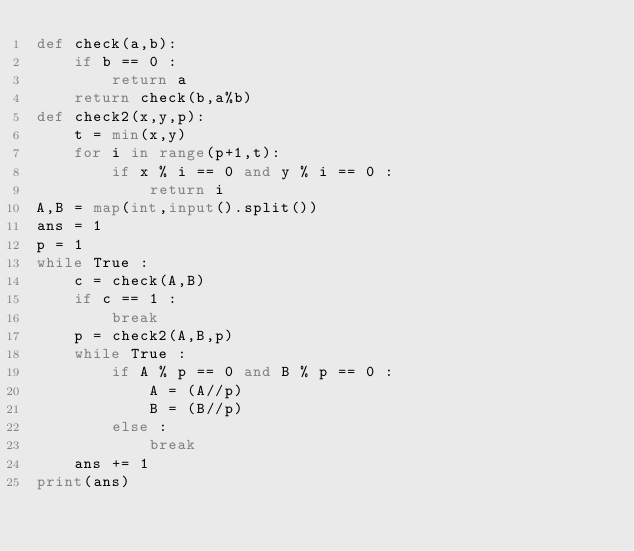<code> <loc_0><loc_0><loc_500><loc_500><_Python_>def check(a,b):
    if b == 0 :
        return a
    return check(b,a%b)
def check2(x,y,p):
    t = min(x,y)
    for i in range(p+1,t):
        if x % i == 0 and y % i == 0 :
            return i
A,B = map(int,input().split())
ans = 1
p = 1
while True :
    c = check(A,B)
    if c == 1 :
        break
    p = check2(A,B,p)
    while True :
        if A % p == 0 and B % p == 0 :
            A = (A//p)
            B = (B//p)
        else :
            break
    ans += 1
print(ans)</code> 